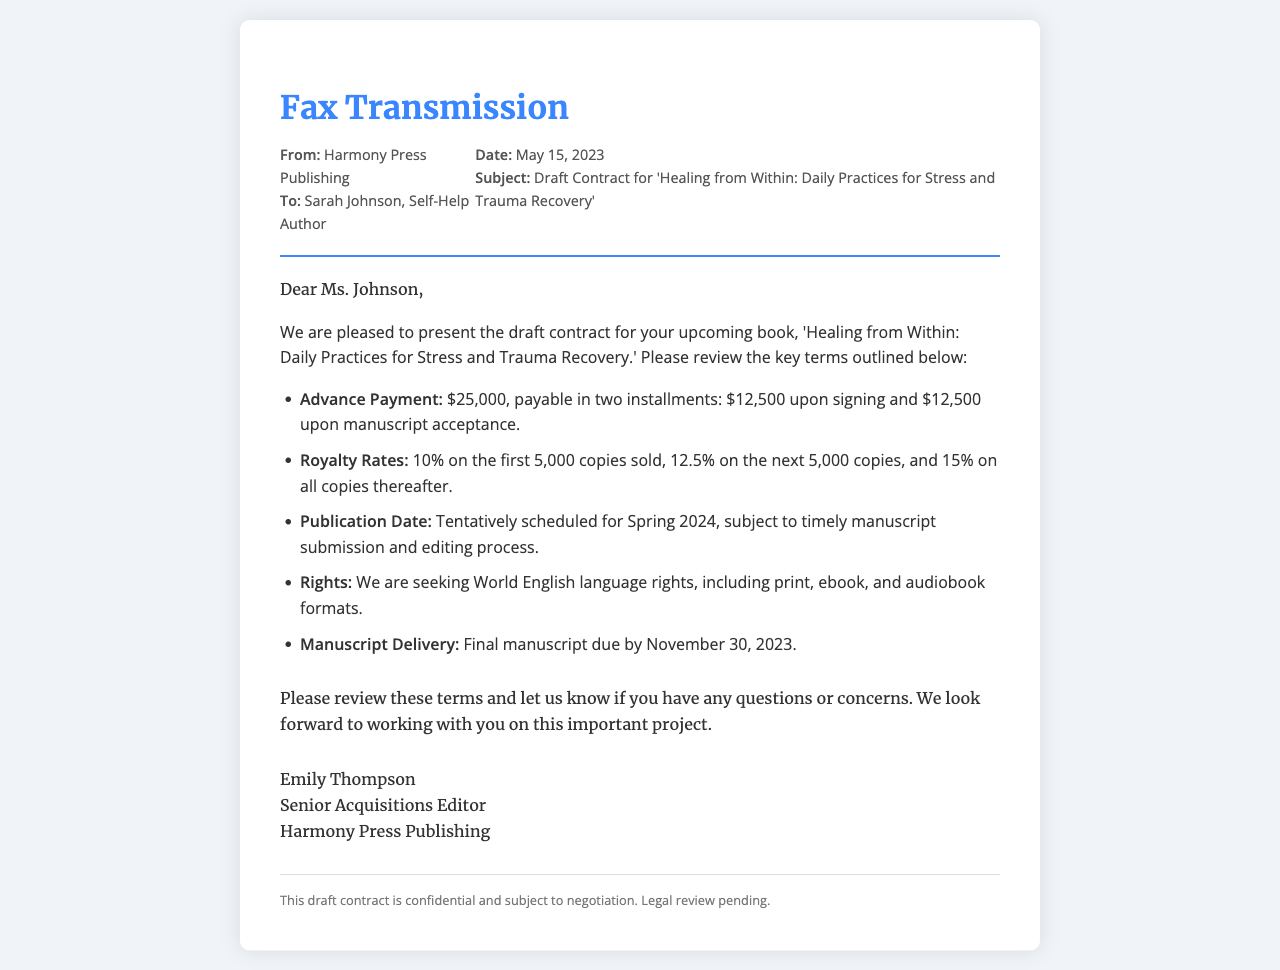what is the advance payment amount? The advance payment amount is specified in the document as $25,000.
Answer: $25,000 how many installments is the advance payment divided into? The document states that the advance payment is payable in two installments.
Answer: Two what are the royalty rates for the first 5,000 copies sold? The document provides specific royalty rates, indicating it is 10% on the first 5,000 copies.
Answer: 10% when is the final manuscript due? The document mentions that the final manuscript is due by November 30, 2023.
Answer: November 30, 2023 what is the publication date tentatively scheduled for? The publication date is mentioned as tentatively scheduled for Spring 2024.
Answer: Spring 2024 who is the sender of the fax? The sender of the fax, as indicated in the document, is Harmony Press Publishing.
Answer: Harmony Press Publishing what is the title of the upcoming book? The document specifies the title of the upcoming book as 'Healing from Within: Daily Practices for Stress and Trauma Recovery.'
Answer: Healing from Within: Daily Practices for Stress and Trauma Recovery what rights are being sought for the book? The rights being sought, as mentioned in the document, are World English language rights.
Answer: World English language rights 